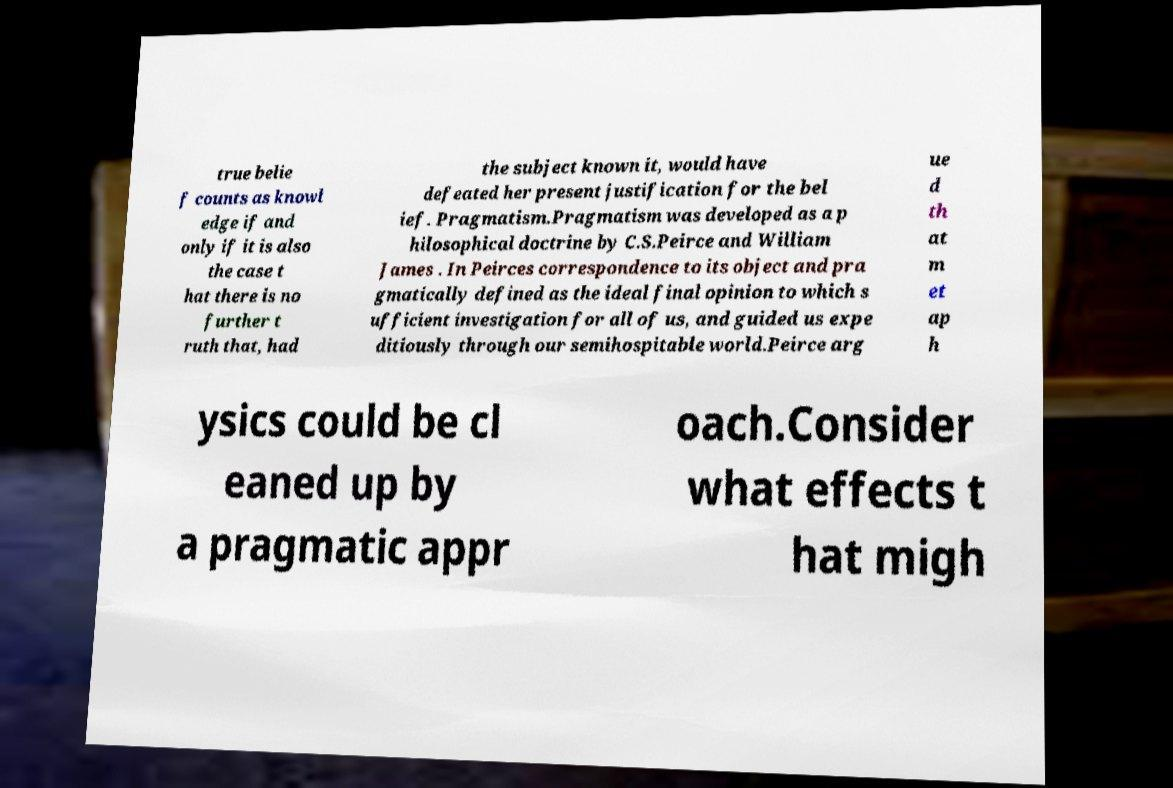Could you extract and type out the text from this image? true belie f counts as knowl edge if and only if it is also the case t hat there is no further t ruth that, had the subject known it, would have defeated her present justification for the bel ief. Pragmatism.Pragmatism was developed as a p hilosophical doctrine by C.S.Peirce and William James . In Peirces correspondence to its object and pra gmatically defined as the ideal final opinion to which s ufficient investigation for all of us, and guided us expe ditiously through our semihospitable world.Peirce arg ue d th at m et ap h ysics could be cl eaned up by a pragmatic appr oach.Consider what effects t hat migh 